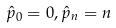<formula> <loc_0><loc_0><loc_500><loc_500>\hat { p } _ { 0 } = 0 , \hat { p } _ { n } = n</formula> 